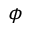Convert formula to latex. <formula><loc_0><loc_0><loc_500><loc_500>\phi</formula> 